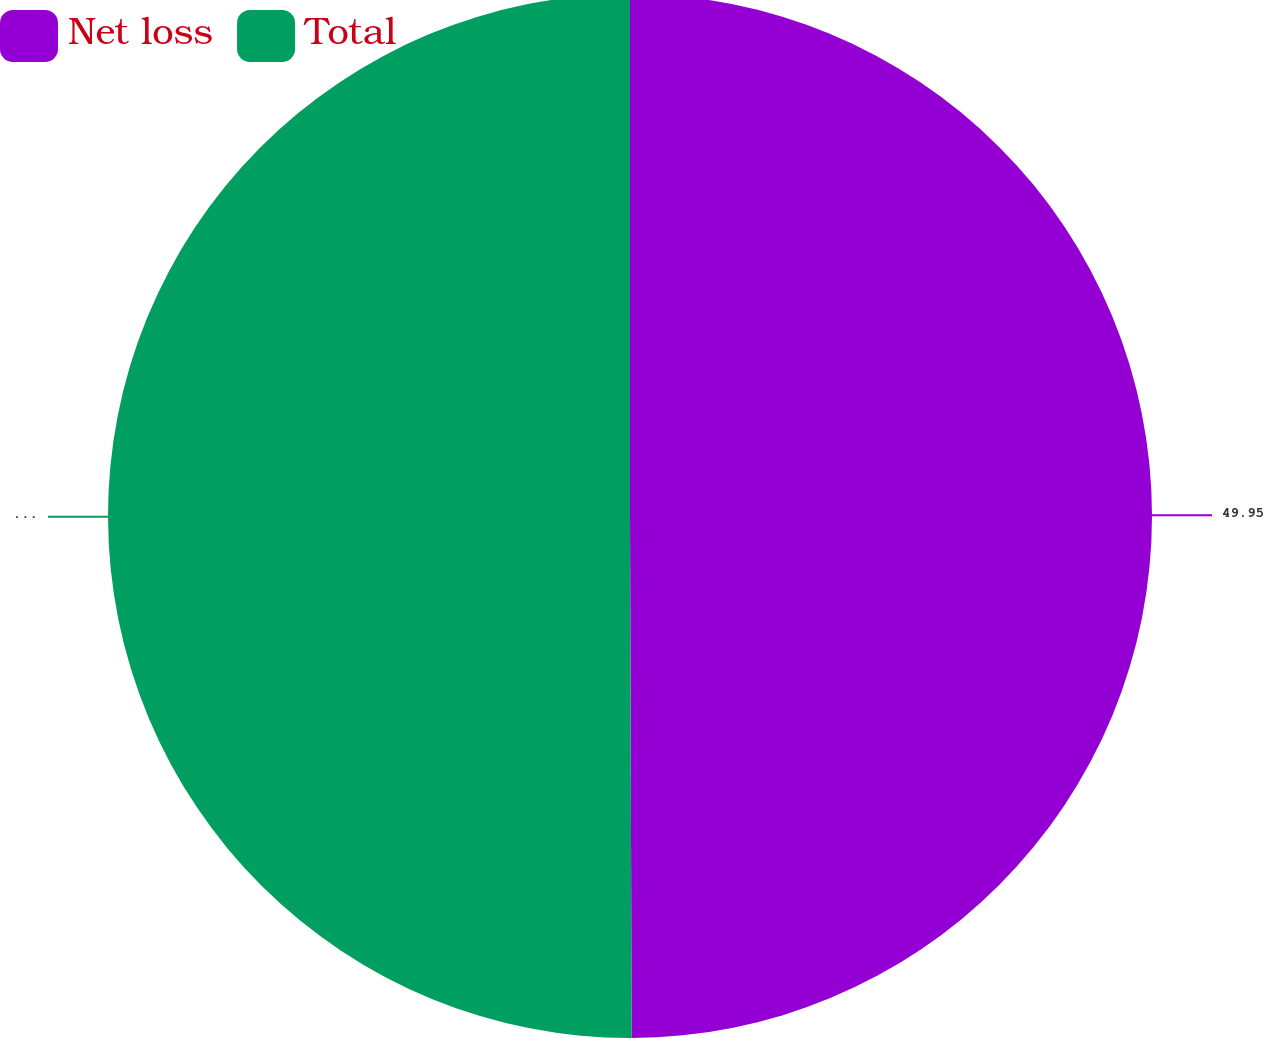<chart> <loc_0><loc_0><loc_500><loc_500><pie_chart><fcel>Net loss<fcel>Total<nl><fcel>49.95%<fcel>50.05%<nl></chart> 